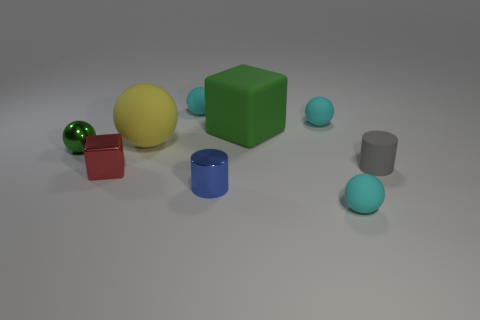There is a matte thing in front of the small cylinder that is in front of the small cube; what color is it?
Offer a very short reply. Cyan. How big is the rubber ball that is both in front of the rubber cube and behind the small gray matte object?
Ensure brevity in your answer.  Large. Are there any other things that have the same color as the tiny block?
Keep it short and to the point. No. What is the shape of the tiny red object that is made of the same material as the tiny green ball?
Your answer should be very brief. Cube. Is the shape of the small red metal thing the same as the large rubber thing to the right of the blue cylinder?
Provide a succinct answer. Yes. What is the material of the small cyan object that is in front of the small gray rubber cylinder that is in front of the small green shiny object?
Ensure brevity in your answer.  Rubber. Are there the same number of blue metallic objects right of the gray rubber cylinder and tiny red rubber cylinders?
Give a very brief answer. Yes. Does the block behind the gray rubber cylinder have the same color as the ball that is left of the yellow matte sphere?
Provide a succinct answer. Yes. How many small matte objects are to the left of the tiny gray matte object and right of the blue shiny cylinder?
Keep it short and to the point. 2. What number of other objects are the same shape as the small red object?
Your response must be concise. 1. 